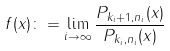<formula> <loc_0><loc_0><loc_500><loc_500>f ( x ) \colon = \lim _ { i \to \infty } \frac { P _ { k _ { i } + 1 , n _ { i } } ( x ) } { P _ { k _ { i } , n _ { i } } ( x ) }</formula> 